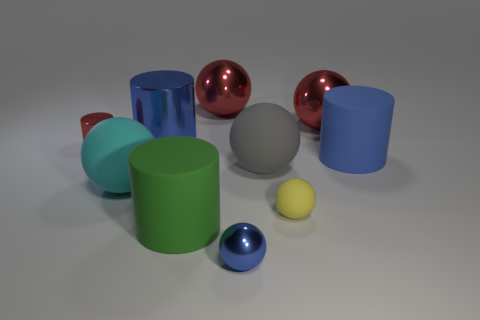Is there another matte object that has the same shape as the large blue rubber thing? Yes, there is a large gray matte object that shares the same spherical shape as the large blue glossy object. 